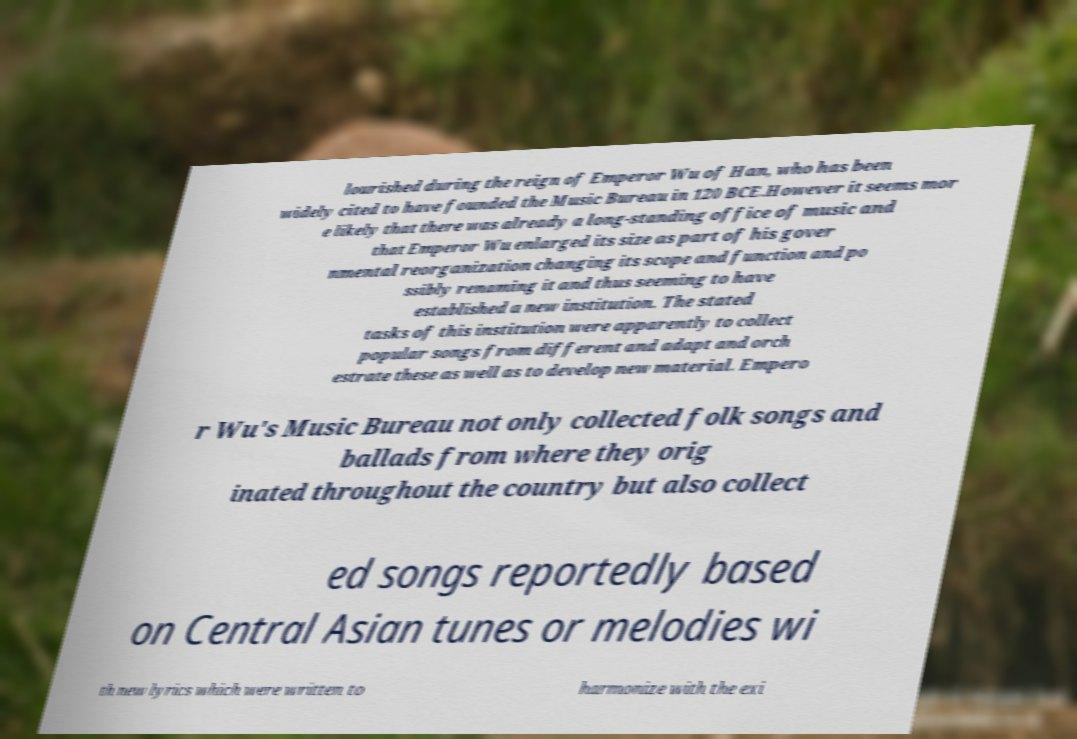Could you assist in decoding the text presented in this image and type it out clearly? lourished during the reign of Emperor Wu of Han, who has been widely cited to have founded the Music Bureau in 120 BCE.However it seems mor e likely that there was already a long-standing office of music and that Emperor Wu enlarged its size as part of his gover nmental reorganization changing its scope and function and po ssibly renaming it and thus seeming to have established a new institution. The stated tasks of this institution were apparently to collect popular songs from different and adapt and orch estrate these as well as to develop new material. Empero r Wu's Music Bureau not only collected folk songs and ballads from where they orig inated throughout the country but also collect ed songs reportedly based on Central Asian tunes or melodies wi th new lyrics which were written to harmonize with the exi 